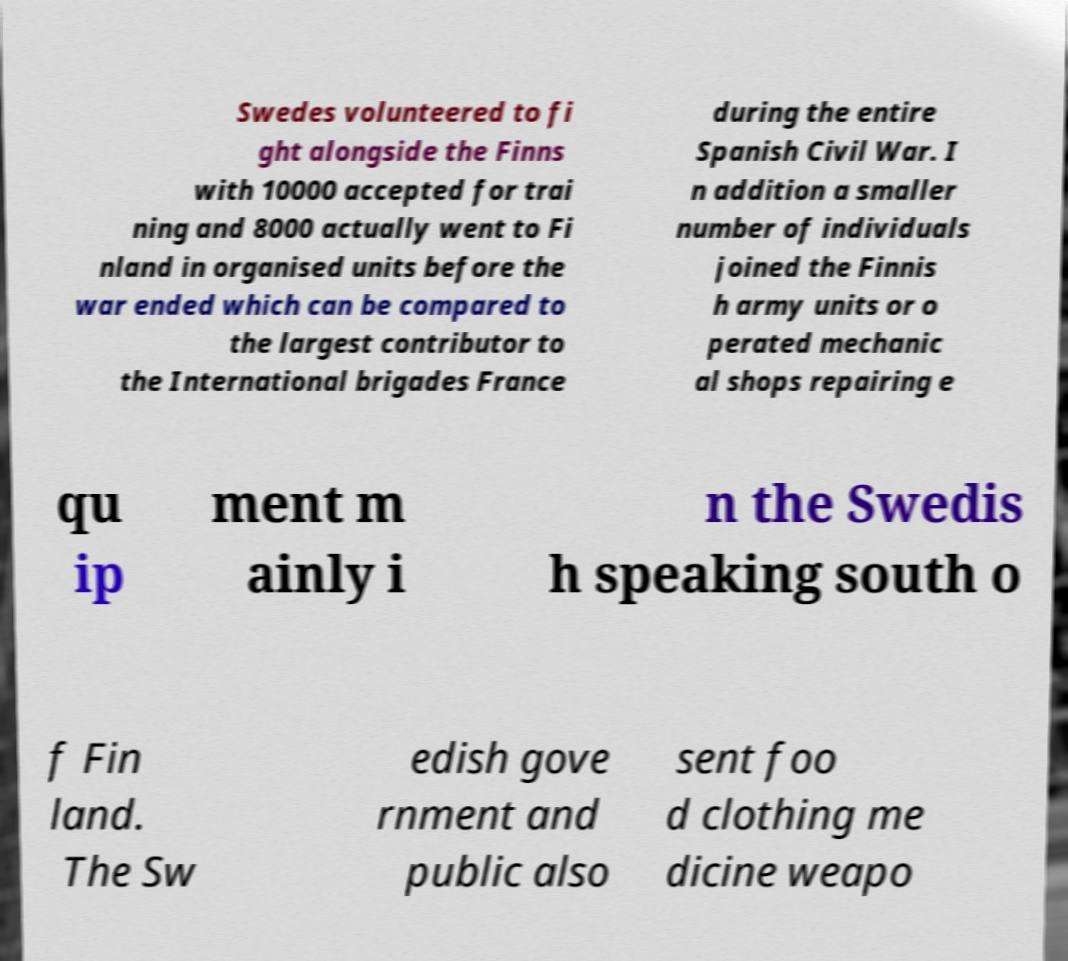For documentation purposes, I need the text within this image transcribed. Could you provide that? Swedes volunteered to fi ght alongside the Finns with 10000 accepted for trai ning and 8000 actually went to Fi nland in organised units before the war ended which can be compared to the largest contributor to the International brigades France during the entire Spanish Civil War. I n addition a smaller number of individuals joined the Finnis h army units or o perated mechanic al shops repairing e qu ip ment m ainly i n the Swedis h speaking south o f Fin land. The Sw edish gove rnment and public also sent foo d clothing me dicine weapo 